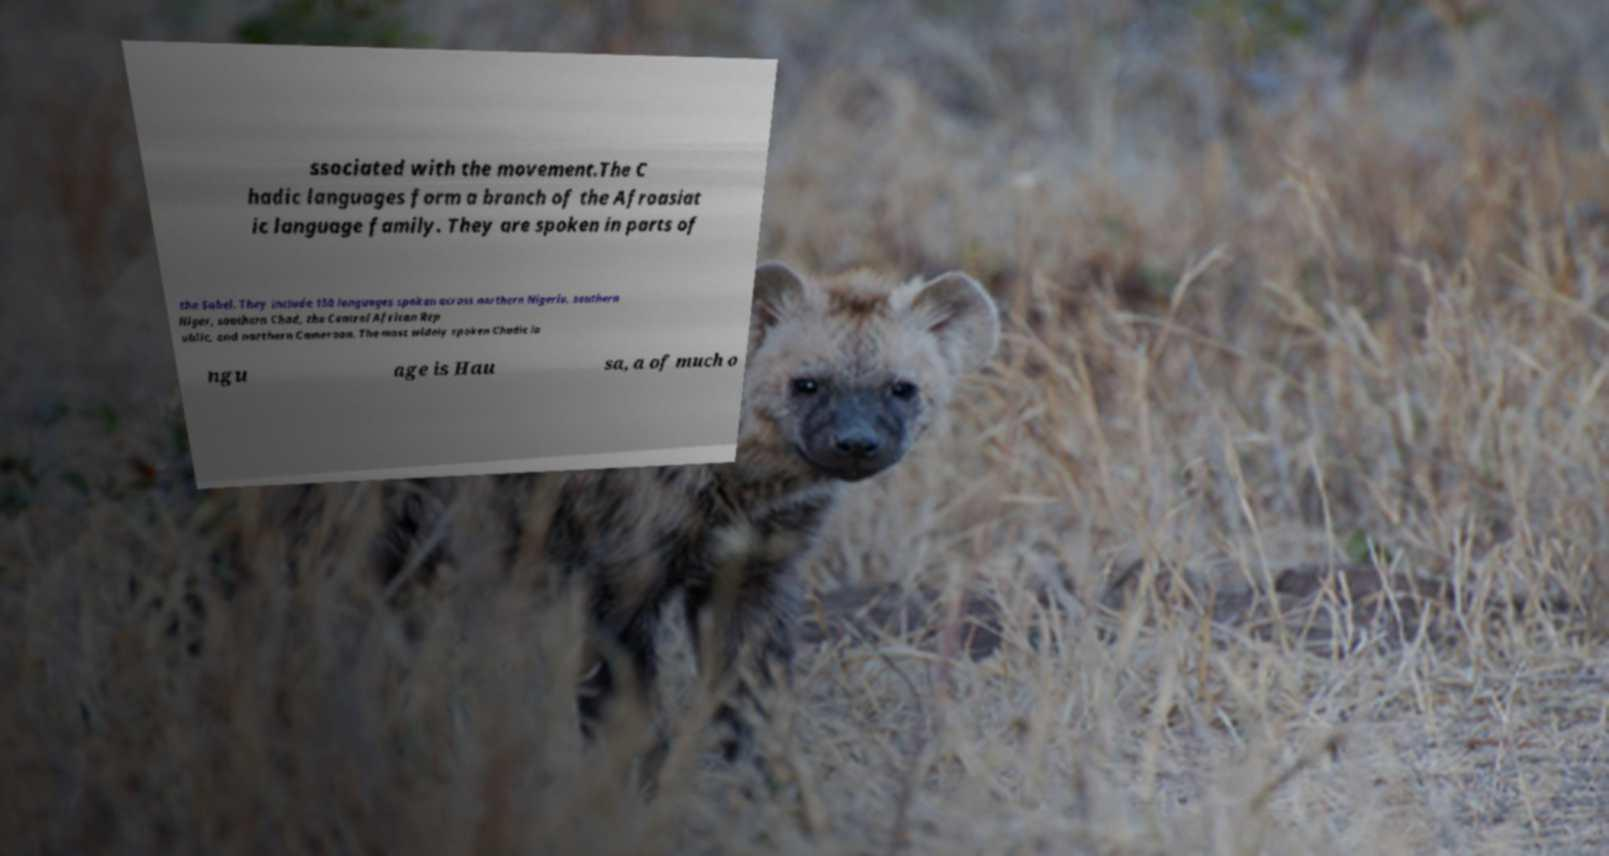Can you accurately transcribe the text from the provided image for me? ssociated with the movement.The C hadic languages form a branch of the Afroasiat ic language family. They are spoken in parts of the Sahel. They include 150 languages spoken across northern Nigeria, southern Niger, southern Chad, the Central African Rep ublic, and northern Cameroon. The most widely spoken Chadic la ngu age is Hau sa, a of much o 